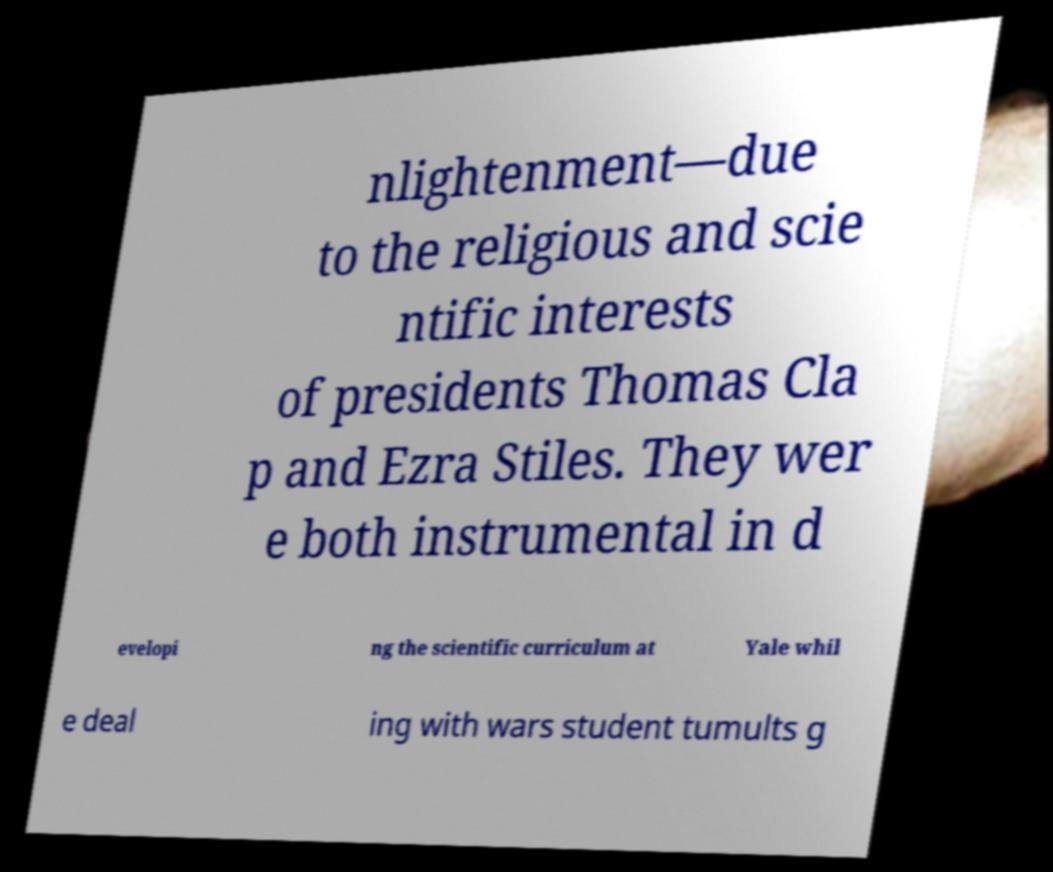Could you assist in decoding the text presented in this image and type it out clearly? nlightenment—due to the religious and scie ntific interests of presidents Thomas Cla p and Ezra Stiles. They wer e both instrumental in d evelopi ng the scientific curriculum at Yale whil e deal ing with wars student tumults g 